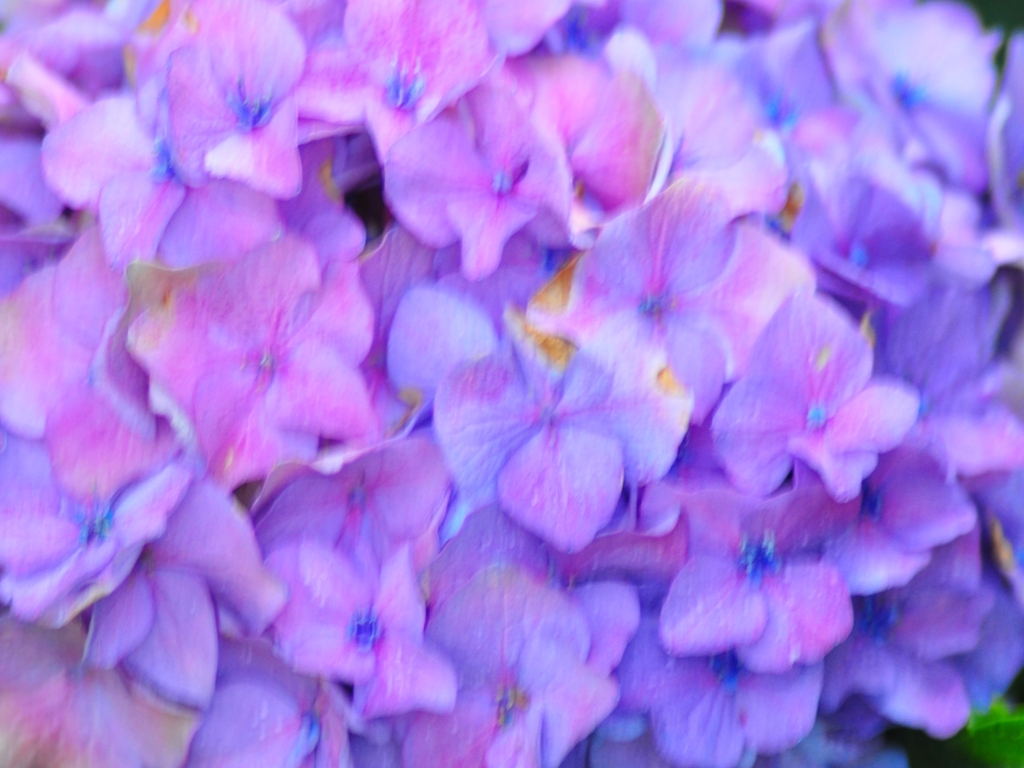What type of flowers are shown in this image? The image appears to showcase a cluster of hydrangea flowers, characterized by their large, round flower heads made up of numerous smaller blooms. 